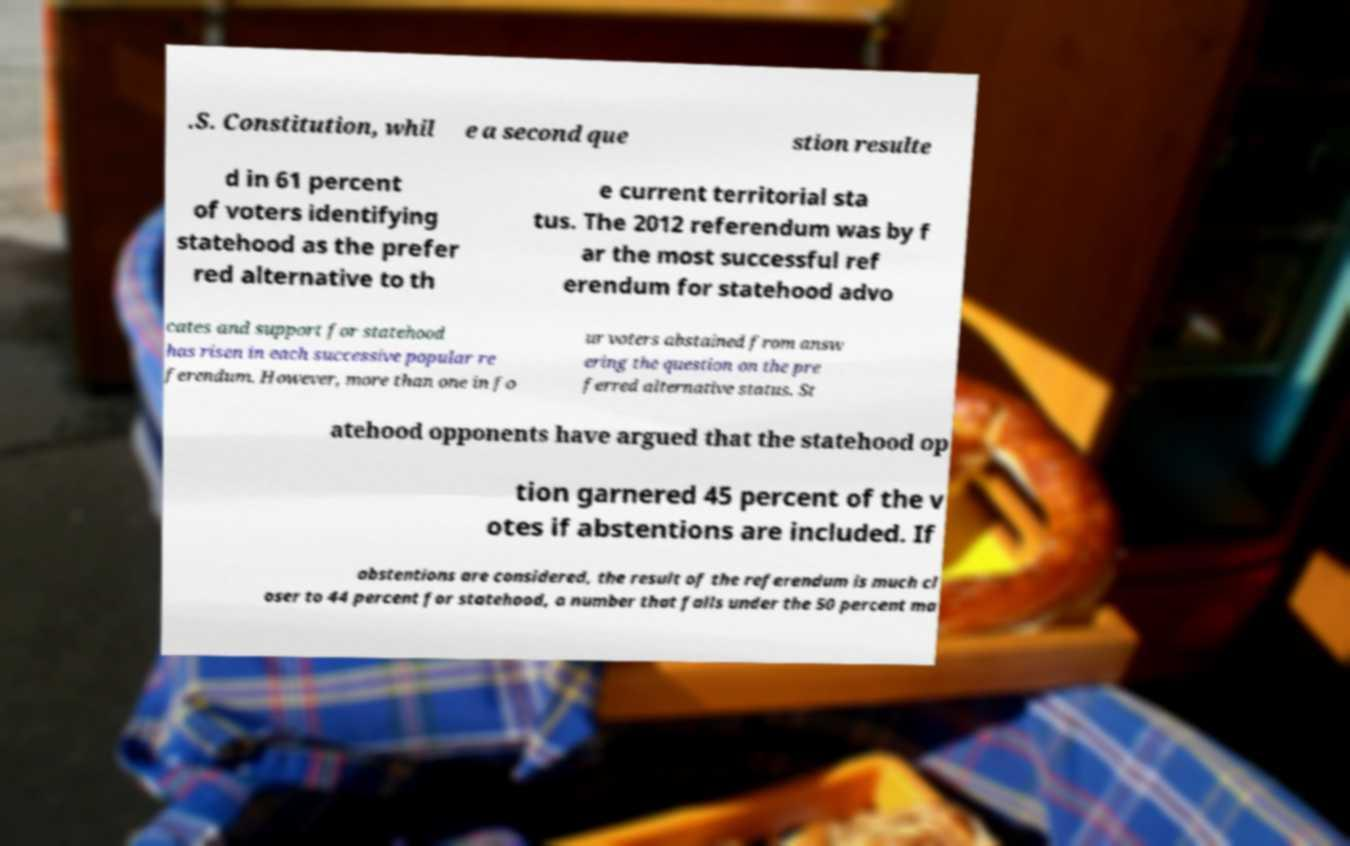For documentation purposes, I need the text within this image transcribed. Could you provide that? .S. Constitution, whil e a second que stion resulte d in 61 percent of voters identifying statehood as the prefer red alternative to th e current territorial sta tus. The 2012 referendum was by f ar the most successful ref erendum for statehood advo cates and support for statehood has risen in each successive popular re ferendum. However, more than one in fo ur voters abstained from answ ering the question on the pre ferred alternative status. St atehood opponents have argued that the statehood op tion garnered 45 percent of the v otes if abstentions are included. If abstentions are considered, the result of the referendum is much cl oser to 44 percent for statehood, a number that falls under the 50 percent ma 